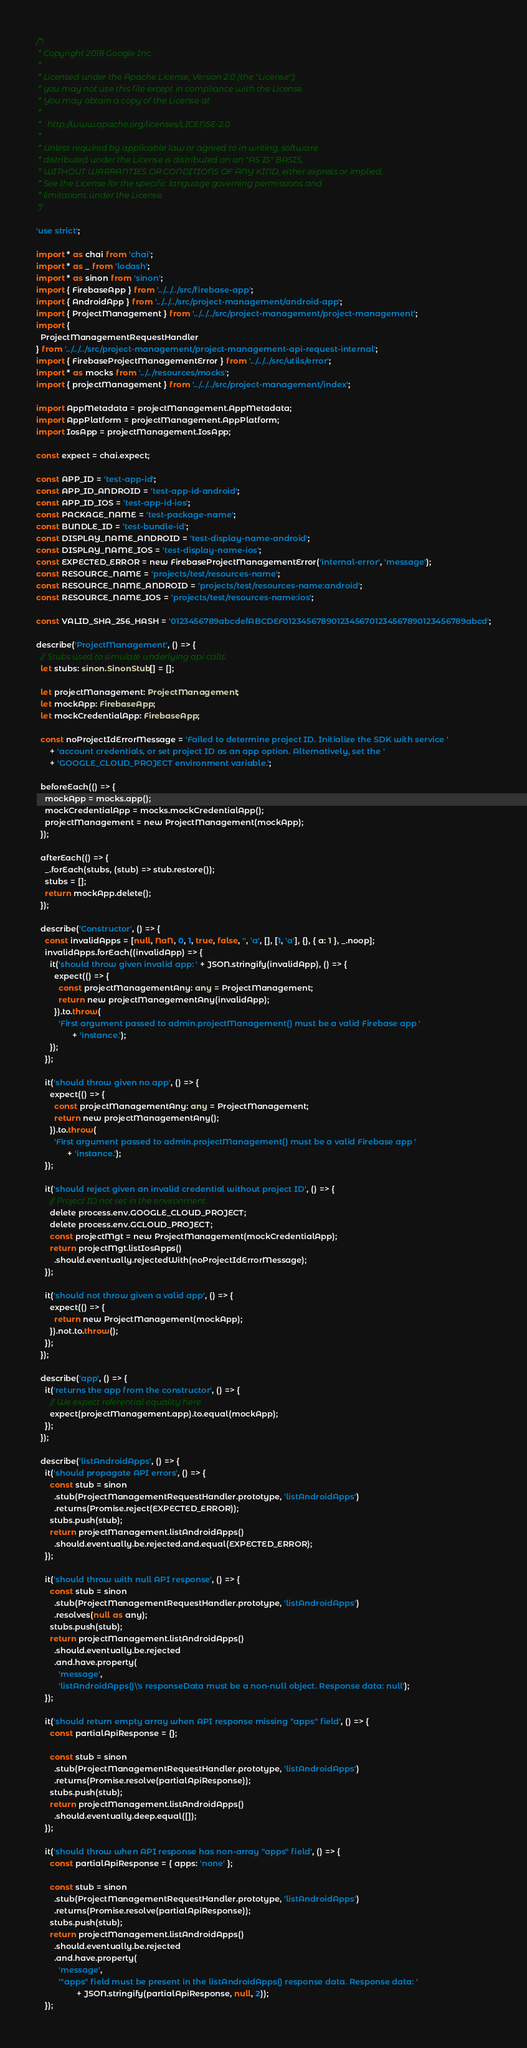<code> <loc_0><loc_0><loc_500><loc_500><_TypeScript_>/*!
 * Copyright 2018 Google Inc.
 *
 * Licensed under the Apache License, Version 2.0 (the "License");
 * you may not use this file except in compliance with the License.
 * You may obtain a copy of the License at
 *
 *   http://www.apache.org/licenses/LICENSE-2.0
 *
 * Unless required by applicable law or agreed to in writing, software
 * distributed under the License is distributed on an "AS IS" BASIS,
 * WITHOUT WARRANTIES OR CONDITIONS OF ANY KIND, either express or implied.
 * See the License for the specific language governing permissions and
 * limitations under the License.
 */

'use strict';

import * as chai from 'chai';
import * as _ from 'lodash';
import * as sinon from 'sinon';
import { FirebaseApp } from '../../../src/firebase-app';
import { AndroidApp } from '../../../src/project-management/android-app';
import { ProjectManagement } from '../../../src/project-management/project-management';
import {
  ProjectManagementRequestHandler
} from '../../../src/project-management/project-management-api-request-internal';
import { FirebaseProjectManagementError } from '../../../src/utils/error';
import * as mocks from '../../resources/mocks';
import { projectManagement } from '../../../src/project-management/index';

import AppMetadata = projectManagement.AppMetadata;
import AppPlatform = projectManagement.AppPlatform;
import IosApp = projectManagement.IosApp;

const expect = chai.expect;

const APP_ID = 'test-app-id';
const APP_ID_ANDROID = 'test-app-id-android';
const APP_ID_IOS = 'test-app-id-ios';
const PACKAGE_NAME = 'test-package-name';
const BUNDLE_ID = 'test-bundle-id';
const DISPLAY_NAME_ANDROID = 'test-display-name-android';
const DISPLAY_NAME_IOS = 'test-display-name-ios';
const EXPECTED_ERROR = new FirebaseProjectManagementError('internal-error', 'message');
const RESOURCE_NAME = 'projects/test/resources-name';
const RESOURCE_NAME_ANDROID = 'projects/test/resources-name:android';
const RESOURCE_NAME_IOS = 'projects/test/resources-name:ios';

const VALID_SHA_256_HASH = '0123456789abcdefABCDEF01234567890123456701234567890123456789abcd';

describe('ProjectManagement', () => {
  // Stubs used to simulate underlying api calls.
  let stubs: sinon.SinonStub[] = [];

  let projectManagement: ProjectManagement;
  let mockApp: FirebaseApp;
  let mockCredentialApp: FirebaseApp;

  const noProjectIdErrorMessage = 'Failed to determine project ID. Initialize the SDK with service '
      + 'account credentials, or set project ID as an app option. Alternatively, set the '
      + 'GOOGLE_CLOUD_PROJECT environment variable.';

  beforeEach(() => {
    mockApp = mocks.app();
    mockCredentialApp = mocks.mockCredentialApp();
    projectManagement = new ProjectManagement(mockApp);
  });

  afterEach(() => {
    _.forEach(stubs, (stub) => stub.restore());
    stubs = [];
    return mockApp.delete();
  });

  describe('Constructor', () => {
    const invalidApps = [null, NaN, 0, 1, true, false, '', 'a', [], [1, 'a'], {}, { a: 1 }, _.noop];
    invalidApps.forEach((invalidApp) => {
      it('should throw given invalid app: ' + JSON.stringify(invalidApp), () => {
        expect(() => {
          const projectManagementAny: any = ProjectManagement;
          return new projectManagementAny(invalidApp);
        }).to.throw(
          'First argument passed to admin.projectManagement() must be a valid Firebase app '
                + 'instance.');
      });
    });

    it('should throw given no app', () => {
      expect(() => {
        const projectManagementAny: any = ProjectManagement;
        return new projectManagementAny();
      }).to.throw(
        'First argument passed to admin.projectManagement() must be a valid Firebase app '
              + 'instance.');
    });

    it('should reject given an invalid credential without project ID', () => {
      // Project ID not set in the environment.
      delete process.env.GOOGLE_CLOUD_PROJECT;
      delete process.env.GCLOUD_PROJECT;
      const projectMgt = new ProjectManagement(mockCredentialApp);
      return projectMgt.listIosApps()
        .should.eventually.rejectedWith(noProjectIdErrorMessage);
    });

    it('should not throw given a valid app', () => {
      expect(() => {
        return new ProjectManagement(mockApp);
      }).not.to.throw();
    });
  });

  describe('app', () => {
    it('returns the app from the constructor', () => {
      // We expect referential equality here
      expect(projectManagement.app).to.equal(mockApp);
    });
  });

  describe('listAndroidApps', () => {
    it('should propagate API errors', () => {
      const stub = sinon
        .stub(ProjectManagementRequestHandler.prototype, 'listAndroidApps')
        .returns(Promise.reject(EXPECTED_ERROR));
      stubs.push(stub);
      return projectManagement.listAndroidApps()
        .should.eventually.be.rejected.and.equal(EXPECTED_ERROR);
    });

    it('should throw with null API response', () => {
      const stub = sinon
        .stub(ProjectManagementRequestHandler.prototype, 'listAndroidApps')
        .resolves(null as any);
      stubs.push(stub);
      return projectManagement.listAndroidApps()
        .should.eventually.be.rejected
        .and.have.property(
          'message',
          'listAndroidApps()\'s responseData must be a non-null object. Response data: null');
    });

    it('should return empty array when API response missing "apps" field', () => {
      const partialApiResponse = {};

      const stub = sinon
        .stub(ProjectManagementRequestHandler.prototype, 'listAndroidApps')
        .returns(Promise.resolve(partialApiResponse));
      stubs.push(stub);
      return projectManagement.listAndroidApps()
        .should.eventually.deep.equal([]);
    });

    it('should throw when API response has non-array "apps" field', () => {
      const partialApiResponse = { apps: 'none' };

      const stub = sinon
        .stub(ProjectManagementRequestHandler.prototype, 'listAndroidApps')
        .returns(Promise.resolve(partialApiResponse));
      stubs.push(stub);
      return projectManagement.listAndroidApps()
        .should.eventually.be.rejected
        .and.have.property(
          'message',
          '"apps" field must be present in the listAndroidApps() response data. Response data: '
                  + JSON.stringify(partialApiResponse, null, 2));
    });
</code> 